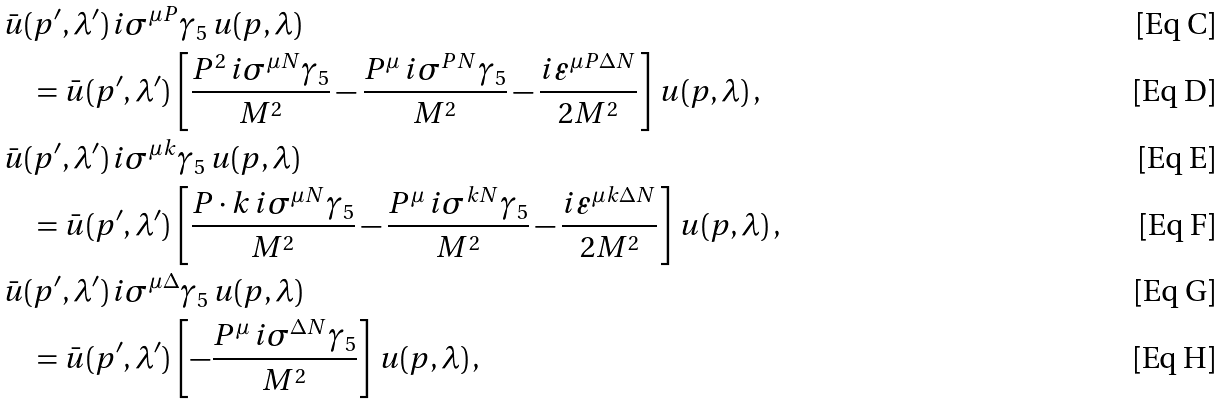Convert formula to latex. <formula><loc_0><loc_0><loc_500><loc_500>& \bar { u } ( p ^ { \prime } , \lambda ^ { \prime } ) \, i \sigma ^ { \mu P } \gamma _ { 5 } \, u ( p , \lambda ) \\ & \quad = \bar { u } ( p ^ { \prime } , \lambda ^ { \prime } ) \, \left [ \frac { P ^ { 2 } \, i \sigma ^ { \mu N } \gamma _ { 5 } } { M ^ { 2 } } - \frac { P ^ { \mu } \, i \sigma ^ { P N } \gamma _ { 5 } } { M ^ { 2 } } - \frac { i \varepsilon ^ { \mu P \Delta N } } { 2 M ^ { 2 } } \right ] \, u ( p , \lambda ) \, , \\ & \bar { u } ( p ^ { \prime } , \lambda ^ { \prime } ) \, i \sigma ^ { \mu k } \gamma _ { 5 } \, u ( p , \lambda ) \\ & \quad = \bar { u } ( p ^ { \prime } , \lambda ^ { \prime } ) \, \left [ \frac { P \cdot k \, i \sigma ^ { \mu N } \gamma _ { 5 } } { M ^ { 2 } } - \frac { P ^ { \mu } \, i \sigma ^ { k N } \gamma _ { 5 } } { M ^ { 2 } } - \frac { i \varepsilon ^ { \mu k \Delta N } } { 2 M ^ { 2 } } \right ] \, u ( p , \lambda ) \, , \\ & \bar { u } ( p ^ { \prime } , \lambda ^ { \prime } ) \, i \sigma ^ { \mu \Delta } \gamma _ { 5 } \, u ( p , \lambda ) \\ & \quad = \bar { u } ( p ^ { \prime } , \lambda ^ { \prime } ) \, \left [ - \frac { P ^ { \mu } \, i \sigma ^ { \Delta N } \gamma _ { 5 } } { M ^ { 2 } } \right ] \, u ( p , \lambda ) \, ,</formula> 